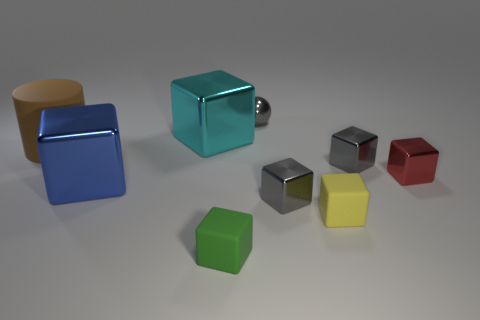The big metallic cube that is behind the thing that is left of the blue shiny object is what color?
Offer a terse response. Cyan. There is a metal sphere that is the same size as the green block; what is its color?
Offer a terse response. Gray. What number of metal objects are gray blocks or tiny objects?
Provide a short and direct response. 4. How many cyan objects are on the left side of the small matte thing that is to the right of the green rubber cube?
Give a very brief answer. 1. How many things are small matte balls or metallic objects that are behind the large cyan metal cube?
Keep it short and to the point. 1. Are there any large yellow objects that have the same material as the red block?
Make the answer very short. No. How many tiny things are left of the red metal cube and behind the tiny yellow cube?
Provide a succinct answer. 3. There is a small thing that is on the left side of the small sphere; what is its material?
Your answer should be very brief. Rubber. There is a red cube that is made of the same material as the small gray sphere; what is its size?
Ensure brevity in your answer.  Small. Are there any gray metallic objects in front of the big rubber object?
Your answer should be very brief. Yes. 